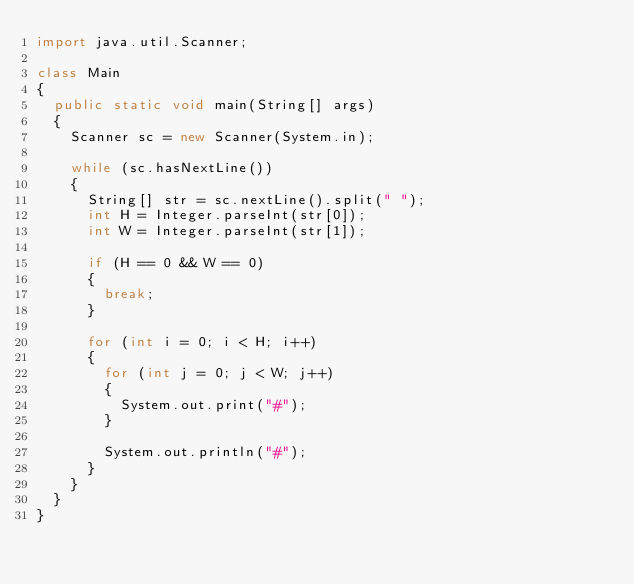Convert code to text. <code><loc_0><loc_0><loc_500><loc_500><_Java_>import java.util.Scanner;

class Main
{
	public static void main(String[] args)
	{
		Scanner sc = new Scanner(System.in);
		
		while (sc.hasNextLine())
		{
			String[] str = sc.nextLine().split(" ");
			int H = Integer.parseInt(str[0]);
			int W = Integer.parseInt(str[1]);
			
			if (H == 0 && W == 0)
			{
				break;
			}
			
			for (int i = 0; i < H; i++)
			{
				for (int j = 0; j < W; j++)
				{
					System.out.print("#");
				}
				
				System.out.println("#");
			}
		}
	}
}</code> 